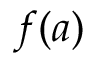<formula> <loc_0><loc_0><loc_500><loc_500>f ( a )</formula> 